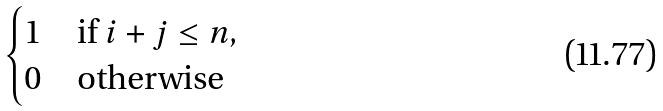<formula> <loc_0><loc_0><loc_500><loc_500>\begin{cases} 1 & \text {if } i + j \leq n , \\ 0 & \text {otherwise} \end{cases}</formula> 